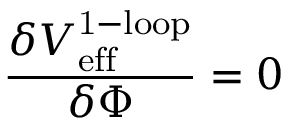Convert formula to latex. <formula><loc_0><loc_0><loc_500><loc_500>\frac { \delta V _ { e f f } ^ { 1 - l o o p } } { \delta \Phi } = 0</formula> 